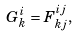<formula> <loc_0><loc_0><loc_500><loc_500>G ^ { i } _ { k } = F ^ { i j } _ { k j } ,</formula> 